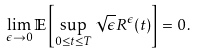<formula> <loc_0><loc_0><loc_500><loc_500>\lim _ { \epsilon \rightarrow 0 } \mathbb { E } \left [ \sup _ { 0 \leq t \leq T } \sqrt { \epsilon } R ^ { \epsilon } ( t ) \right ] = 0 \, .</formula> 